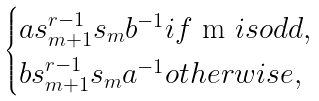Convert formula to latex. <formula><loc_0><loc_0><loc_500><loc_500>\begin{cases} a s _ { m + 1 } ^ { r - 1 } s _ { m } b ^ { - 1 } i f $ m $ i s o d d , \\ b s _ { m + 1 } ^ { r - 1 } s _ { m } a ^ { - 1 } o t h e r w i s e , \end{cases}</formula> 